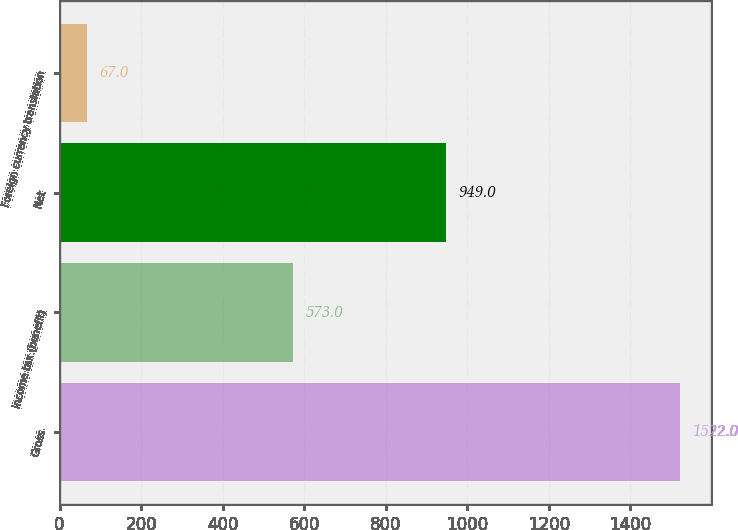<chart> <loc_0><loc_0><loc_500><loc_500><bar_chart><fcel>Gross<fcel>Income tax (benefit)<fcel>Net<fcel>Foreign currency translation<nl><fcel>1522<fcel>573<fcel>949<fcel>67<nl></chart> 